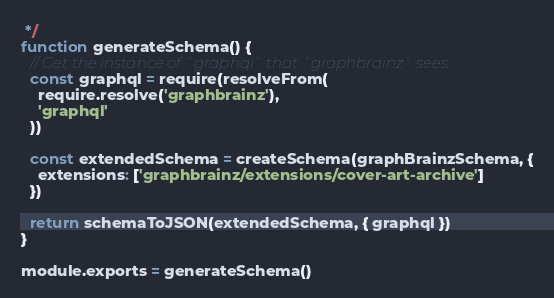Convert code to text. <code><loc_0><loc_0><loc_500><loc_500><_JavaScript_> */
function generateSchema() {
  // Get the instance of `graphql` that `graphbrainz` sees.
  const graphql = require(resolveFrom(
    require.resolve('graphbrainz'),
    'graphql'
  ))

  const extendedSchema = createSchema(graphBrainzSchema, {
    extensions: ['graphbrainz/extensions/cover-art-archive']
  })

  return schemaToJSON(extendedSchema, { graphql })
}

module.exports = generateSchema()
</code> 